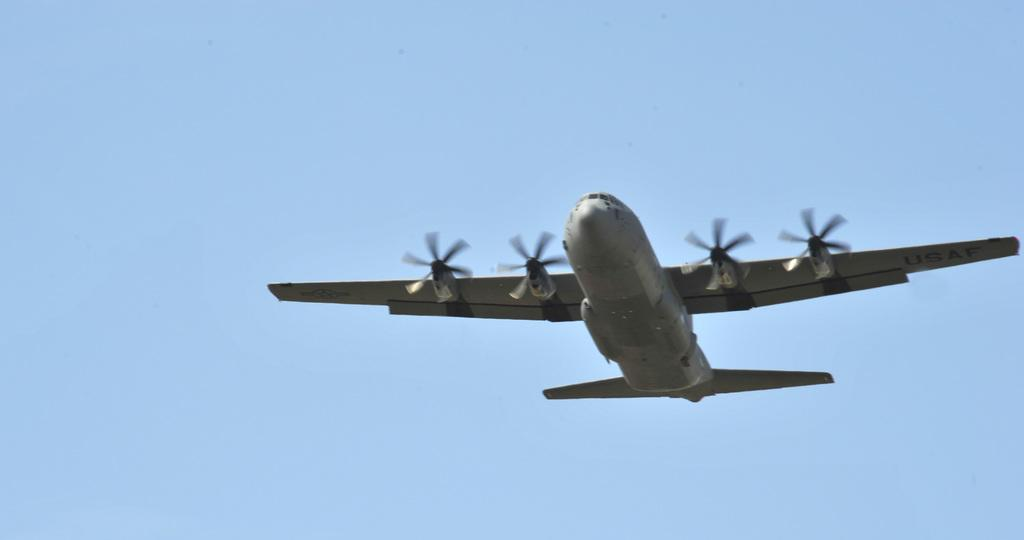What is the main subject of the image? The main subject of the image is an airplane. Where is the airplane located in the image? The airplane is in the air. How would you describe the sky in the image? The sky is cloudy and pale blue. What type of request can be heard from the passengers in the image? There are no passengers or sounds present in the image, so it is not possible to determine any requests. 